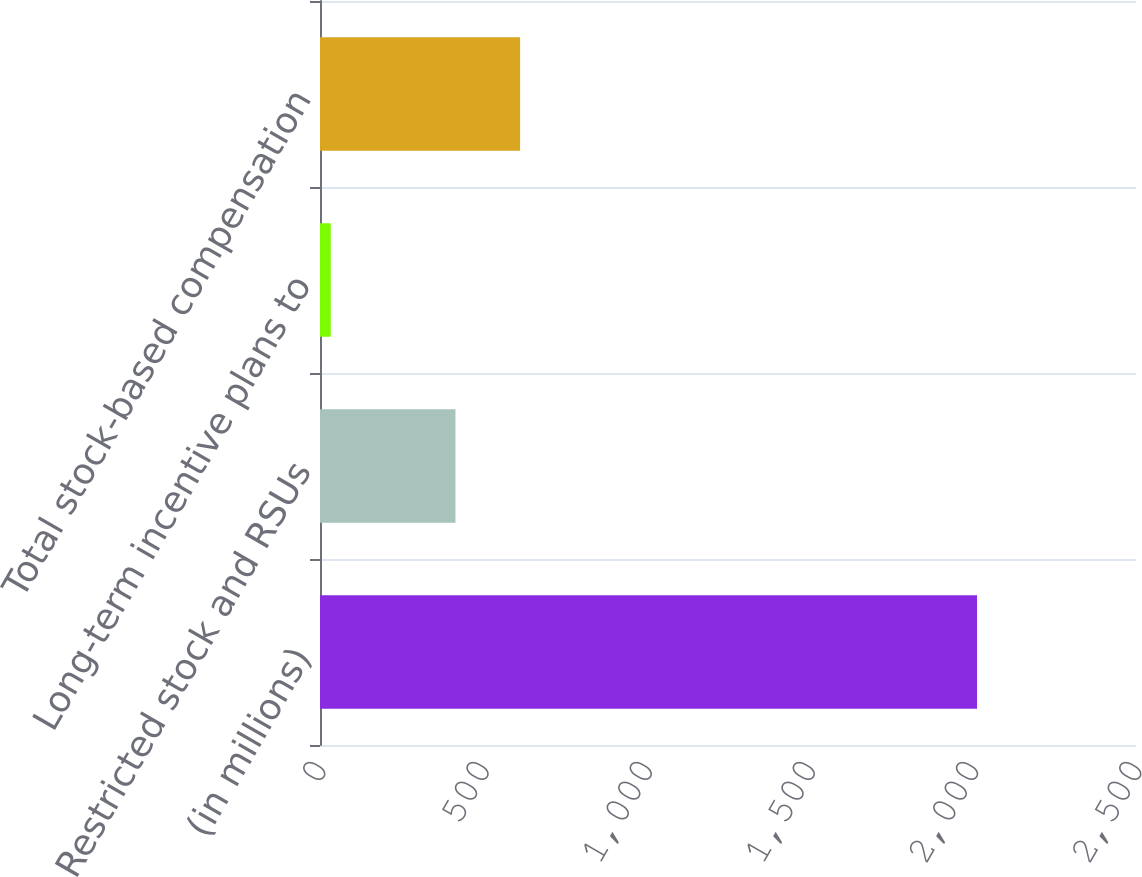Convert chart to OTSL. <chart><loc_0><loc_0><loc_500><loc_500><bar_chart><fcel>(in millions)<fcel>Restricted stock and RSUs<fcel>Long-term incentive plans to<fcel>Total stock-based compensation<nl><fcel>2013<fcel>415<fcel>33<fcel>613<nl></chart> 